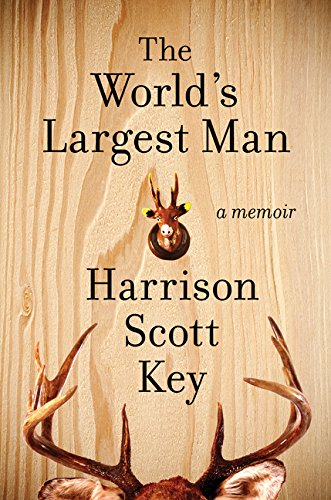How has the author's background influenced his writing style? Harrison Scott Key's distinctive writing style is deeply influenced by his Southern roots, often incorporating storytelling techniques characteristic of Southern oral traditions, mixed with a flair for exaggerated humor and introspection. 